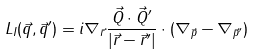<formula> <loc_0><loc_0><loc_500><loc_500>L _ { I } ( \vec { q } , \vec { q } ^ { \prime } ) = i \nabla _ { \vec { r } } \frac { \vec { Q } \cdot \vec { Q } ^ { \prime } } { | \vec { r } - \vec { r } ^ { \prime } | } \cdot ( \nabla _ { \vec { p } } - \nabla _ { \vec { p } ^ { \prime } } )</formula> 